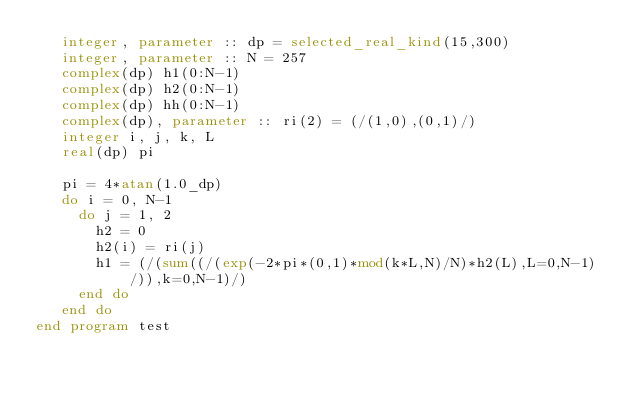Convert code to text. <code><loc_0><loc_0><loc_500><loc_500><_FORTRAN_>   integer, parameter :: dp = selected_real_kind(15,300)
   integer, parameter :: N = 257
   complex(dp) h1(0:N-1)
   complex(dp) h2(0:N-1)
   complex(dp) hh(0:N-1)
   complex(dp), parameter :: ri(2) = (/(1,0),(0,1)/)
   integer i, j, k, L
   real(dp) pi

   pi = 4*atan(1.0_dp)
   do i = 0, N-1
     do j = 1, 2
       h2 = 0
       h2(i) = ri(j)
       h1 = (/(sum((/(exp(-2*pi*(0,1)*mod(k*L,N)/N)*h2(L),L=0,N-1)/)),k=0,N-1)/)
     end do
   end do
end program test 
</code> 